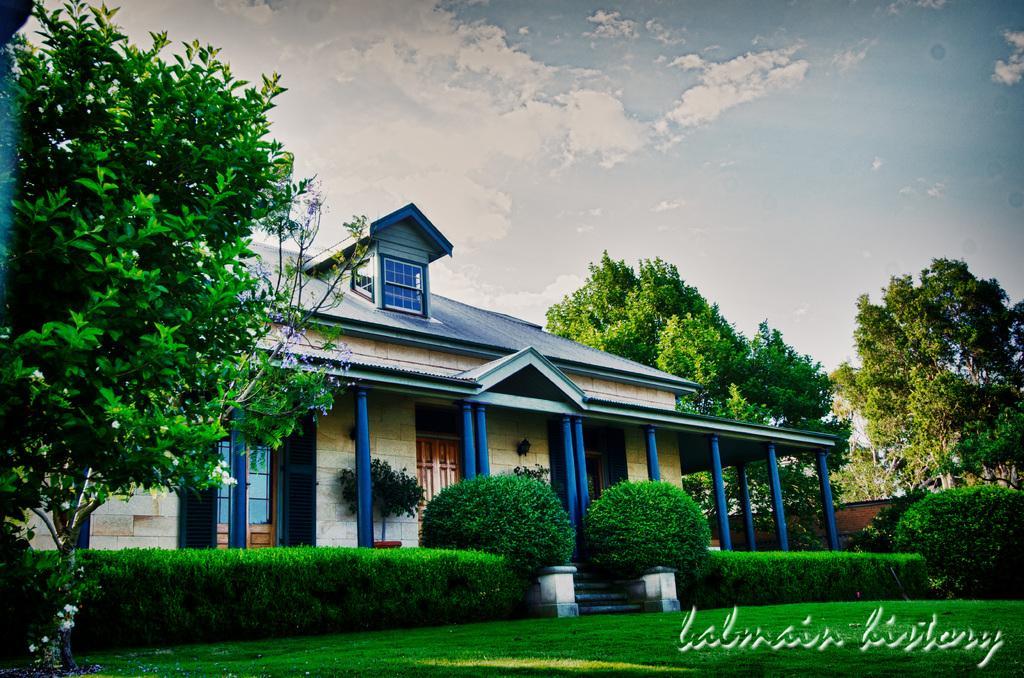Describe this image in one or two sentences. In this image we can see a house. There are many trees and plants in the image. There is a grassy lawn in the image. There is a blue and a slightly cloudy sky in the image. 